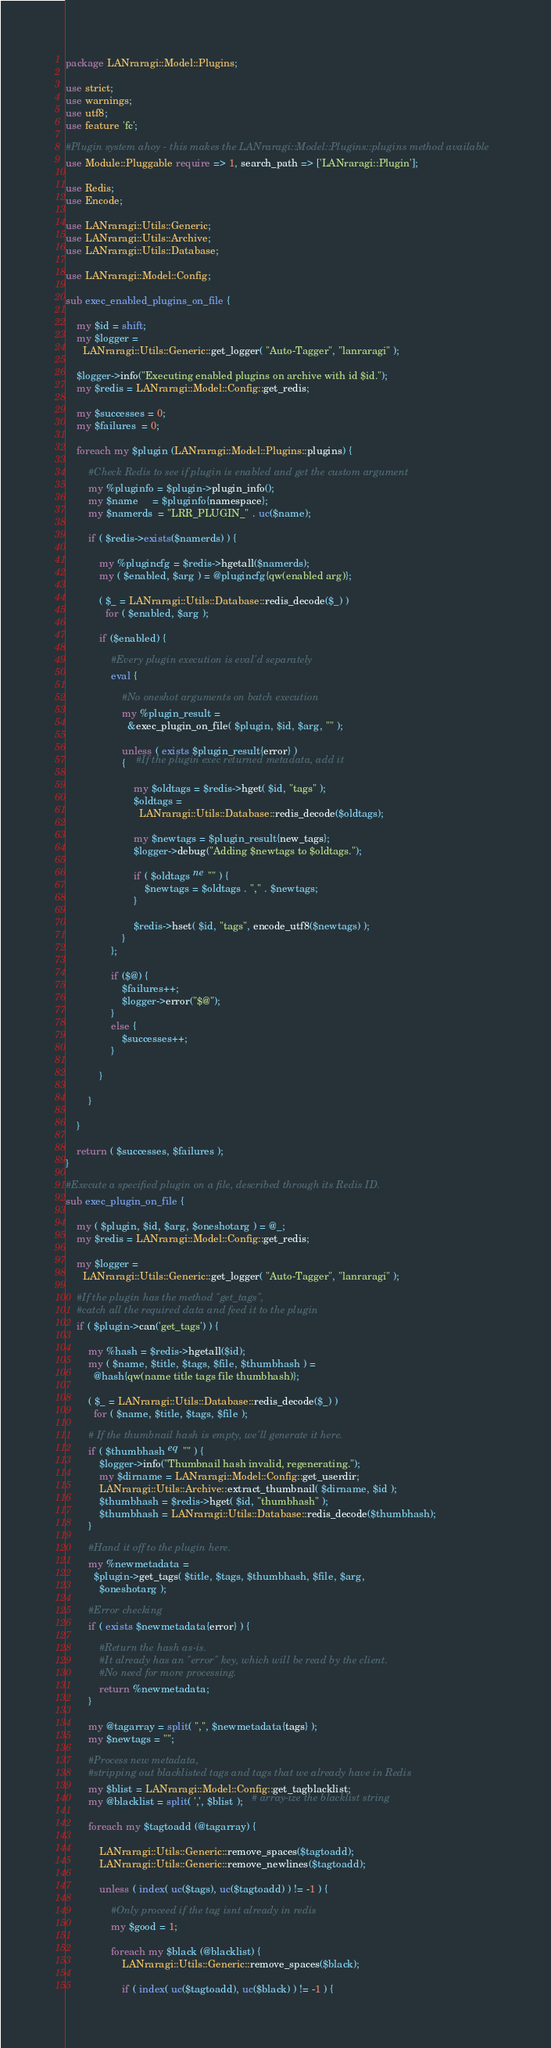Convert code to text. <code><loc_0><loc_0><loc_500><loc_500><_Perl_>package LANraragi::Model::Plugins;

use strict;
use warnings;
use utf8;
use feature 'fc';

#Plugin system ahoy - this makes the LANraragi::Model::Plugins::plugins method available
use Module::Pluggable require => 1, search_path => ['LANraragi::Plugin'];

use Redis;
use Encode;

use LANraragi::Utils::Generic;
use LANraragi::Utils::Archive;
use LANraragi::Utils::Database;

use LANraragi::Model::Config;

sub exec_enabled_plugins_on_file {

    my $id = shift;
    my $logger =
      LANraragi::Utils::Generic::get_logger( "Auto-Tagger", "lanraragi" );

    $logger->info("Executing enabled plugins on archive with id $id.");
    my $redis = LANraragi::Model::Config::get_redis;

    my $successes = 0;
    my $failures  = 0;

    foreach my $plugin (LANraragi::Model::Plugins::plugins) {

        #Check Redis to see if plugin is enabled and get the custom argument
        my %pluginfo = $plugin->plugin_info();
        my $name     = $pluginfo{namespace};
        my $namerds  = "LRR_PLUGIN_" . uc($name);

        if ( $redis->exists($namerds) ) {

            my %plugincfg = $redis->hgetall($namerds);
            my ( $enabled, $arg ) = @plugincfg{qw(enabled arg)};

            ( $_ = LANraragi::Utils::Database::redis_decode($_) )
              for ( $enabled, $arg );

            if ($enabled) {

                #Every plugin execution is eval'd separately
                eval {

                    #No oneshot arguments on batch execution
                    my %plugin_result =
                      &exec_plugin_on_file( $plugin, $id, $arg, "" );

                    unless ( exists $plugin_result{error} )
                    {    #If the plugin exec returned metadata, add it

                        my $oldtags = $redis->hget( $id, "tags" );
                        $oldtags =
                          LANraragi::Utils::Database::redis_decode($oldtags);

                        my $newtags = $plugin_result{new_tags};
                        $logger->debug("Adding $newtags to $oldtags.");

                        if ( $oldtags ne "" ) {
                            $newtags = $oldtags . "," . $newtags;
                        }

                        $redis->hset( $id, "tags", encode_utf8($newtags) );
                    }
                };

                if ($@) {
                    $failures++;
                    $logger->error("$@");
                }
                else {
                    $successes++;
                }

            }

        }

    }

    return ( $successes, $failures );
}

#Execute a specified plugin on a file, described through its Redis ID.
sub exec_plugin_on_file {

    my ( $plugin, $id, $arg, $oneshotarg ) = @_;
    my $redis = LANraragi::Model::Config::get_redis;

    my $logger =
      LANraragi::Utils::Generic::get_logger( "Auto-Tagger", "lanraragi" );

    #If the plugin has the method "get_tags",
    #catch all the required data and feed it to the plugin
    if ( $plugin->can('get_tags') ) {

        my %hash = $redis->hgetall($id);
        my ( $name, $title, $tags, $file, $thumbhash ) =
          @hash{qw(name title tags file thumbhash)};

        ( $_ = LANraragi::Utils::Database::redis_decode($_) )
          for ( $name, $title, $tags, $file );

        # If the thumbnail hash is empty, we'll generate it here.
        if ( $thumbhash eq "" ) {
            $logger->info("Thumbnail hash invalid, regenerating.");
            my $dirname = LANraragi::Model::Config::get_userdir;
            LANraragi::Utils::Archive::extract_thumbnail( $dirname, $id );
            $thumbhash = $redis->hget( $id, "thumbhash" );
            $thumbhash = LANraragi::Utils::Database::redis_decode($thumbhash);
        }

        #Hand it off to the plugin here.
        my %newmetadata =
          $plugin->get_tags( $title, $tags, $thumbhash, $file, $arg,
            $oneshotarg );

        #Error checking
        if ( exists $newmetadata{error} ) {

            #Return the hash as-is.
            #It already has an "error" key, which will be read by the client.
            #No need for more processing.
            return %newmetadata;
        }

        my @tagarray = split( ",", $newmetadata{tags} );
        my $newtags = "";

        #Process new metadata,
        #stripping out blacklisted tags and tags that we already have in Redis
        my $blist = LANraragi::Model::Config::get_tagblacklist;
        my @blacklist = split( ',', $blist );   # array-ize the blacklist string

        foreach my $tagtoadd (@tagarray) {

            LANraragi::Utils::Generic::remove_spaces($tagtoadd);
            LANraragi::Utils::Generic::remove_newlines($tagtoadd);

            unless ( index( uc($tags), uc($tagtoadd) ) != -1 ) {

                #Only proceed if the tag isnt already in redis
                my $good = 1;

                foreach my $black (@blacklist) {
                    LANraragi::Utils::Generic::remove_spaces($black);

                    if ( index( uc($tagtoadd), uc($black) ) != -1 ) {</code> 